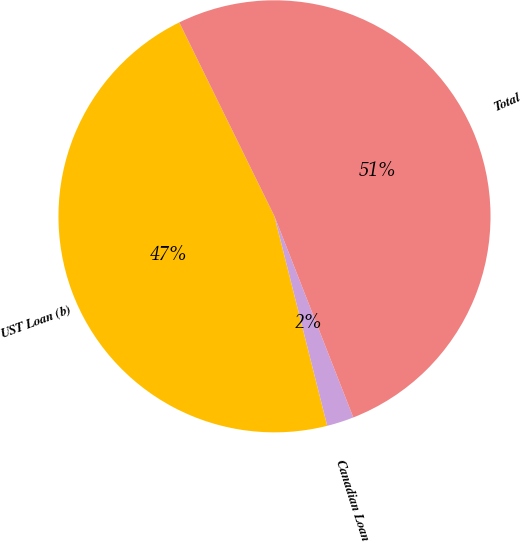Convert chart. <chart><loc_0><loc_0><loc_500><loc_500><pie_chart><fcel>UST Loan (b)<fcel>Canadian Loan<fcel>Total<nl><fcel>46.66%<fcel>2.02%<fcel>51.32%<nl></chart> 